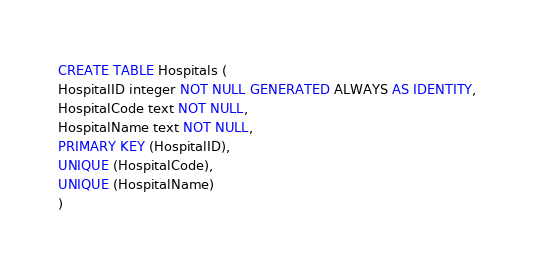Convert code to text. <code><loc_0><loc_0><loc_500><loc_500><_SQL_>CREATE TABLE Hospitals (
HospitalID integer NOT NULL GENERATED ALWAYS AS IDENTITY,
HospitalCode text NOT NULL,
HospitalName text NOT NULL,
PRIMARY KEY (HospitalID),
UNIQUE (HospitalCode),
UNIQUE (HospitalName)
)</code> 